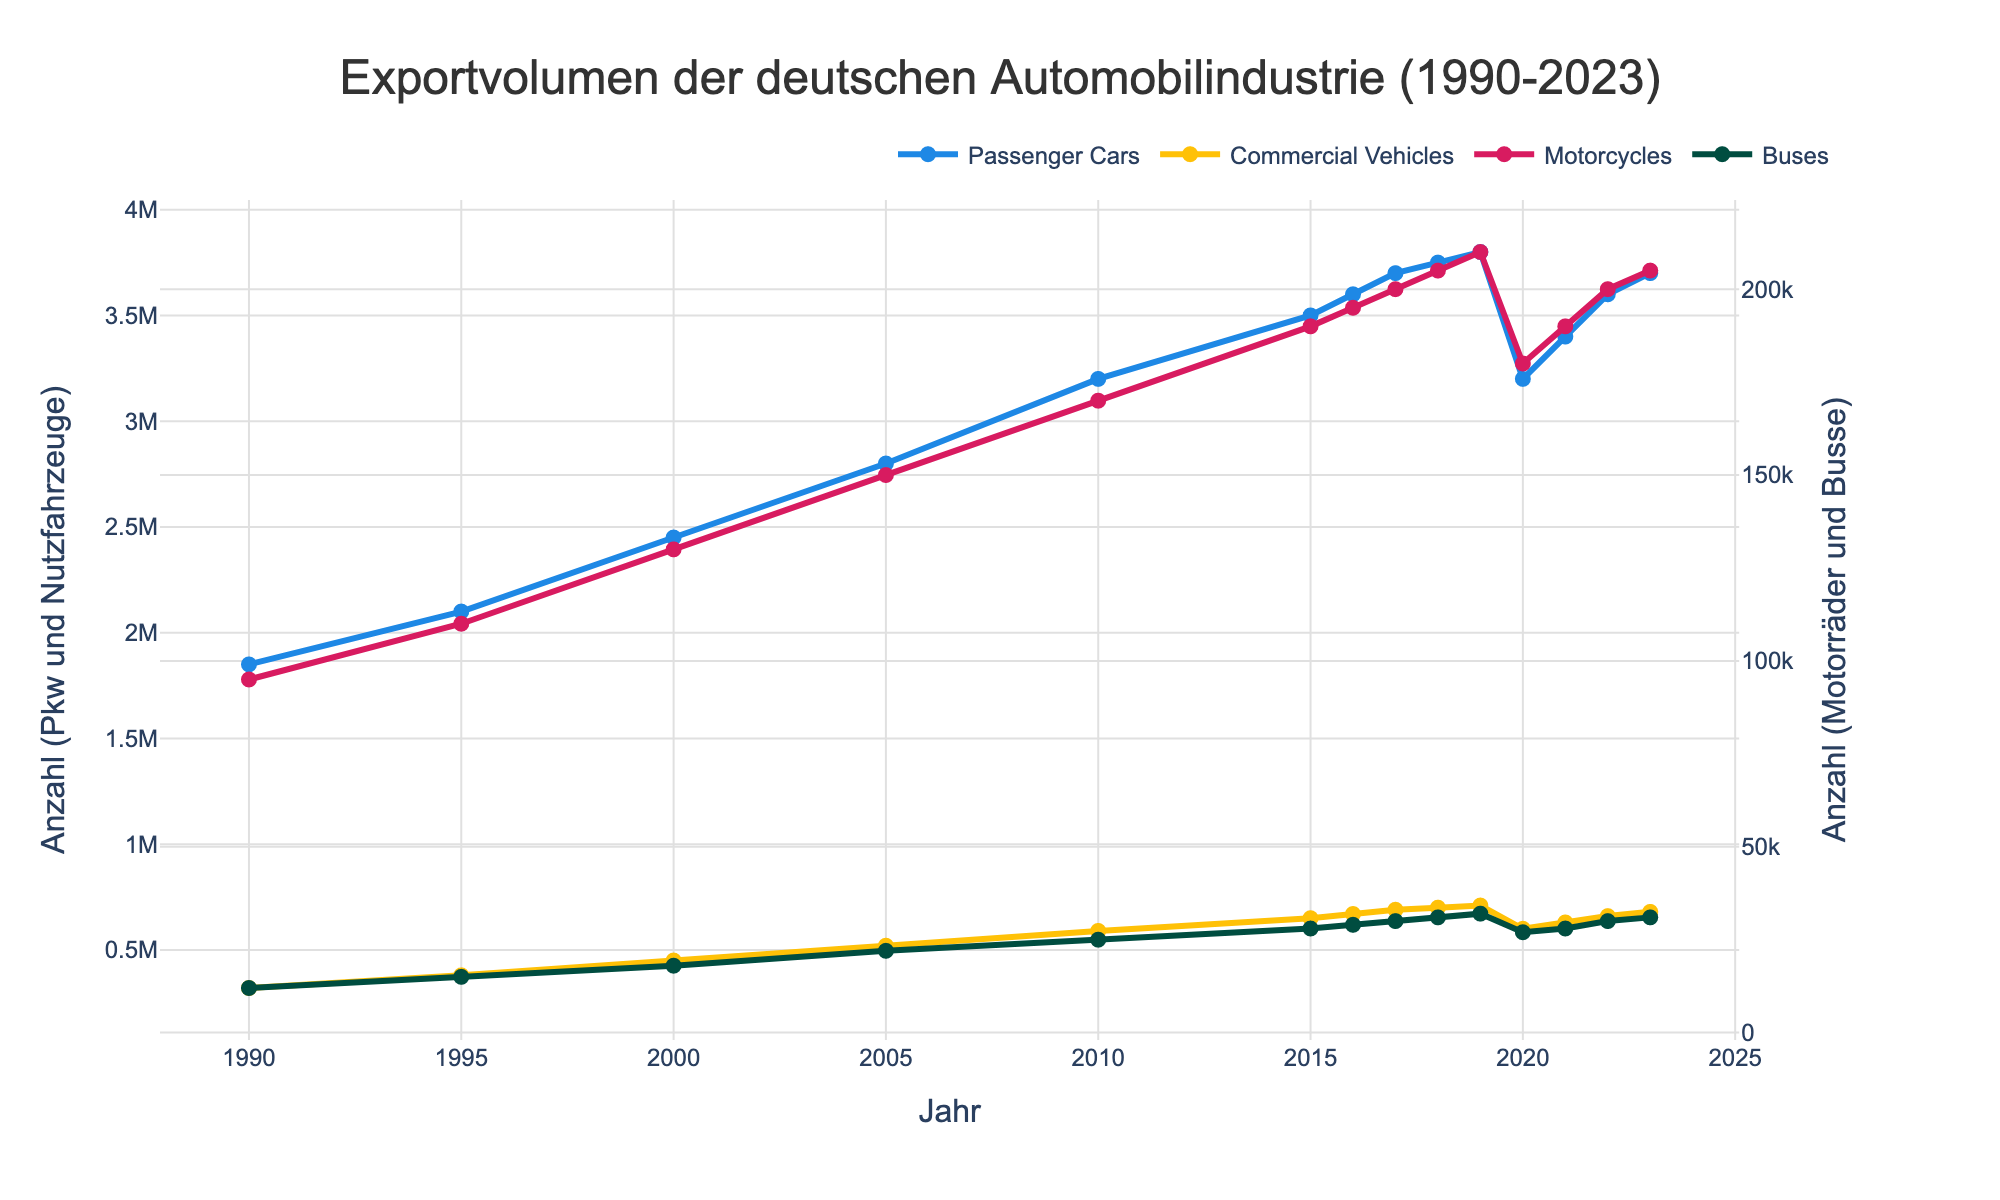What's the trend for Passenger Cars exports from 1990 to 2023? To determine the trend, observe the line corresponding to Passenger Cars. It shows a general increase from 1990 to 2019, a dip in 2020, and then a recovery from 2021 onwards.
Answer: Increasing trend with a dip in 2020 How did the number of Motorcycles exported change from 1990 to 2023? Observe the Motorcycles line from 1990 to 2023. Initially, there is a consistent increase from 1990 until 2019, with a slight dip in 2020, followed by a steady increase again.
Answer: Increased overall with a dip in 2020 Which vehicle type had the highest export volume in 2023? Look at the endpoints of all lines for 2023. Passenger Cars had the highest value.
Answer: Passenger Cars Compare the export volume of Commercial Vehicles and Buses in 2000. Which had more exports? Locate the volumes for both Commercial Vehicles and Buses in 2000. Commercial Vehicles had 450,000, whereas Buses had 18,000.
Answer: Commercial Vehicles What is the average export volume of Buses from 1990 to 2023? Sum the yearly volumes for Buses and divide by the number of years (34). (12,000 + 15,000 + 18,000 + 22,000 + 25,000 + 28,000 + 29,000 + 30,000 + 31,000 + 32,000 + 27,000 + 28,000 + 30,000 + 31,000) / 34 = 23,118.
Answer: 23,118 What happened to the export volume of Passenger Cars between 2019 and 2020? Compare the heights of the Passenger Cars lines in 2019 and 2020. There is a drop from 3,800,000 to 3,200,000.
Answer: Decreased Between which years did Commercial Vehicles exports see the biggest increase? Identify the steepest increase in the Commercial Vehicles line, which is between 2000 and 2005.
Answer: 2000 to 2005 How did the exports of Motorcycles compare to Buses in 2018? Check the values of Motorcycles and Buses in 2018. Motorcycles had 205,000, while Buses had 31,000.
Answer: Motorcycles had higher exports What's the sum of Passenger Cars and Commercial Vehicles exports in 2021? Add the export volumes for Passenger Cars and Commercial Vehicles in 2021. 3,400,000 + 630,000 = 4,030,000.
Answer: 4,030,000 Do any vehicle types show a constant export volume throughout the period? Inspect the lines for all vehicle types for constancy. None of the vehicle types maintain a constant export volume from 1990 to 2023.
Answer: None 